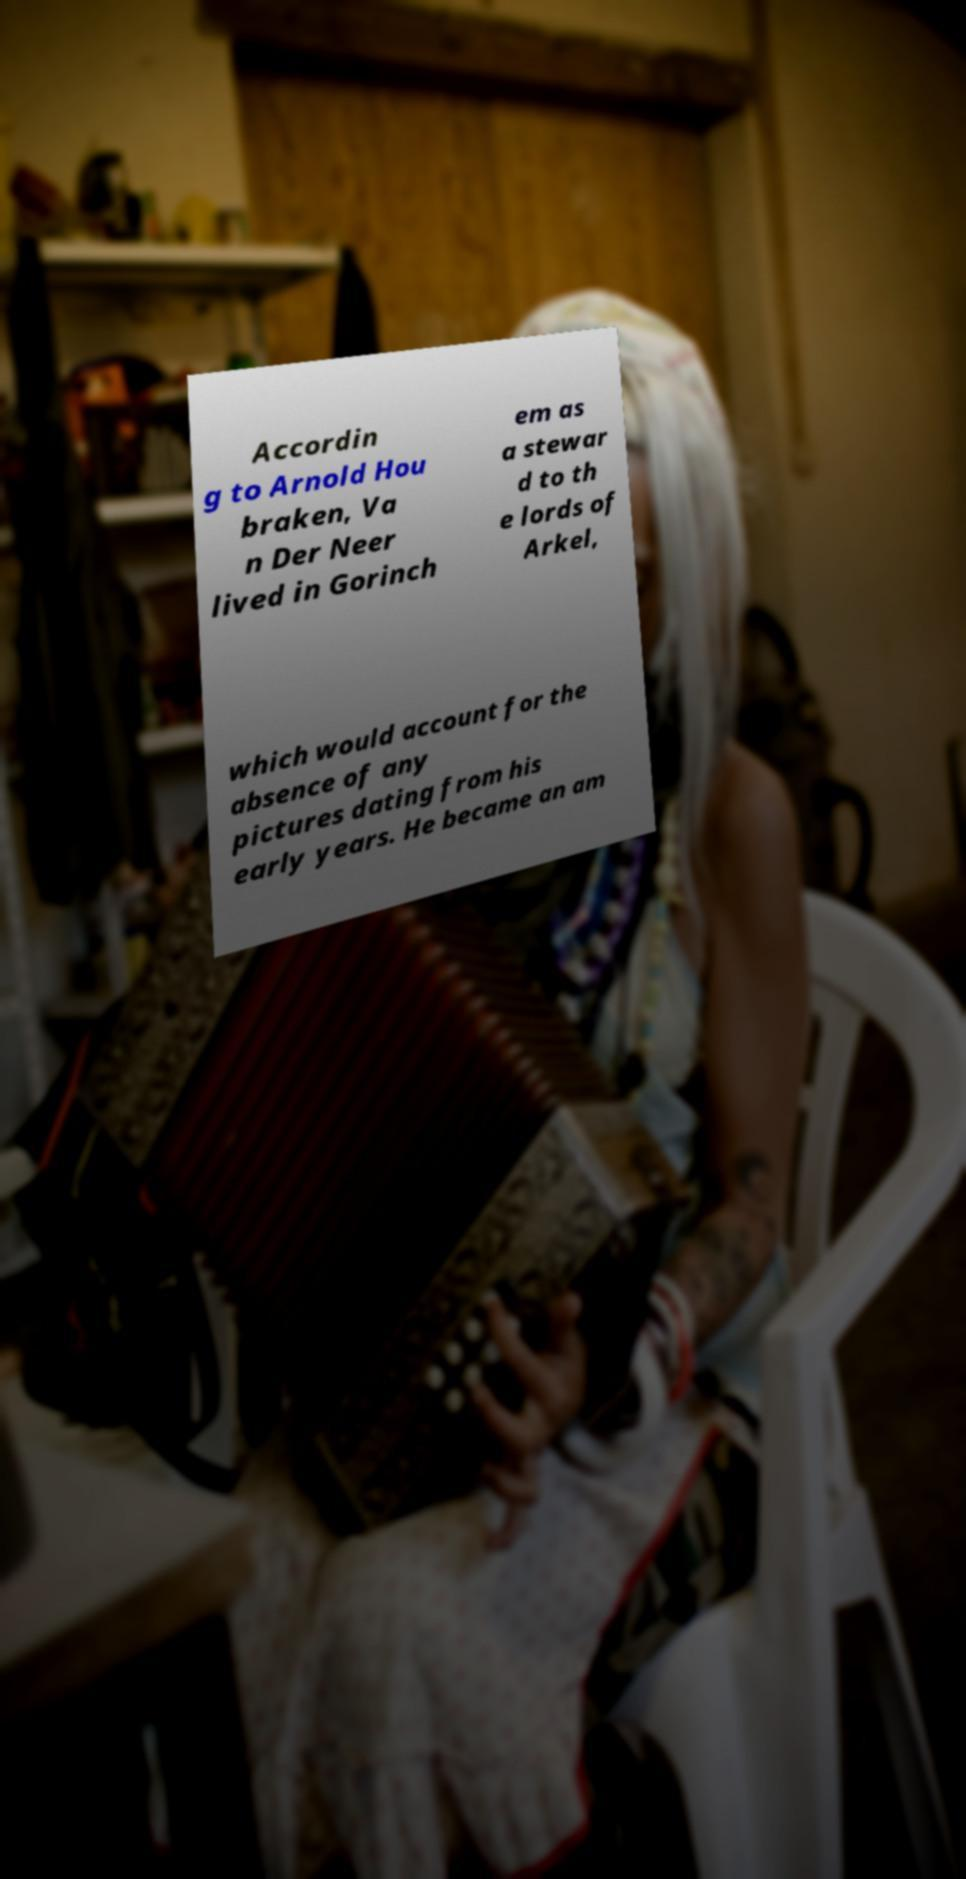Could you assist in decoding the text presented in this image and type it out clearly? Accordin g to Arnold Hou braken, Va n Der Neer lived in Gorinch em as a stewar d to th e lords of Arkel, which would account for the absence of any pictures dating from his early years. He became an am 